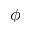Convert formula to latex. <formula><loc_0><loc_0><loc_500><loc_500>\phi</formula> 